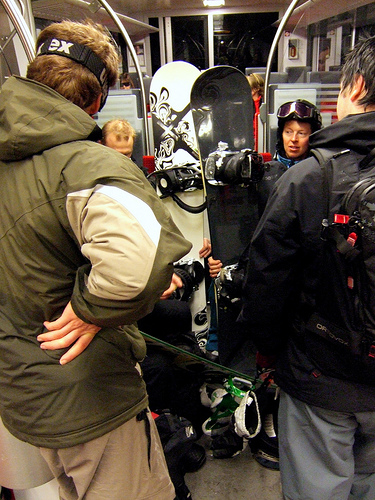<image>
Is the snowboard on the woman? No. The snowboard is not positioned on the woman. They may be near each other, but the snowboard is not supported by or resting on top of the woman. Is the eyeglass on the woman? No. The eyeglass is not positioned on the woman. They may be near each other, but the eyeglass is not supported by or resting on top of the woman. 